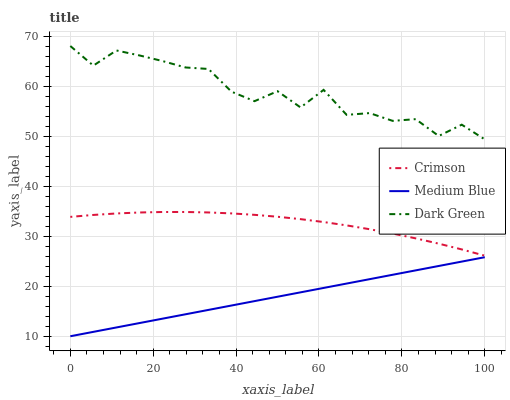Does Medium Blue have the minimum area under the curve?
Answer yes or no. Yes. Does Dark Green have the maximum area under the curve?
Answer yes or no. Yes. Does Dark Green have the minimum area under the curve?
Answer yes or no. No. Does Medium Blue have the maximum area under the curve?
Answer yes or no. No. Is Medium Blue the smoothest?
Answer yes or no. Yes. Is Dark Green the roughest?
Answer yes or no. Yes. Is Dark Green the smoothest?
Answer yes or no. No. Is Medium Blue the roughest?
Answer yes or no. No. Does Medium Blue have the lowest value?
Answer yes or no. Yes. Does Dark Green have the lowest value?
Answer yes or no. No. Does Dark Green have the highest value?
Answer yes or no. Yes. Does Medium Blue have the highest value?
Answer yes or no. No. Is Medium Blue less than Dark Green?
Answer yes or no. Yes. Is Dark Green greater than Medium Blue?
Answer yes or no. Yes. Does Medium Blue intersect Dark Green?
Answer yes or no. No. 